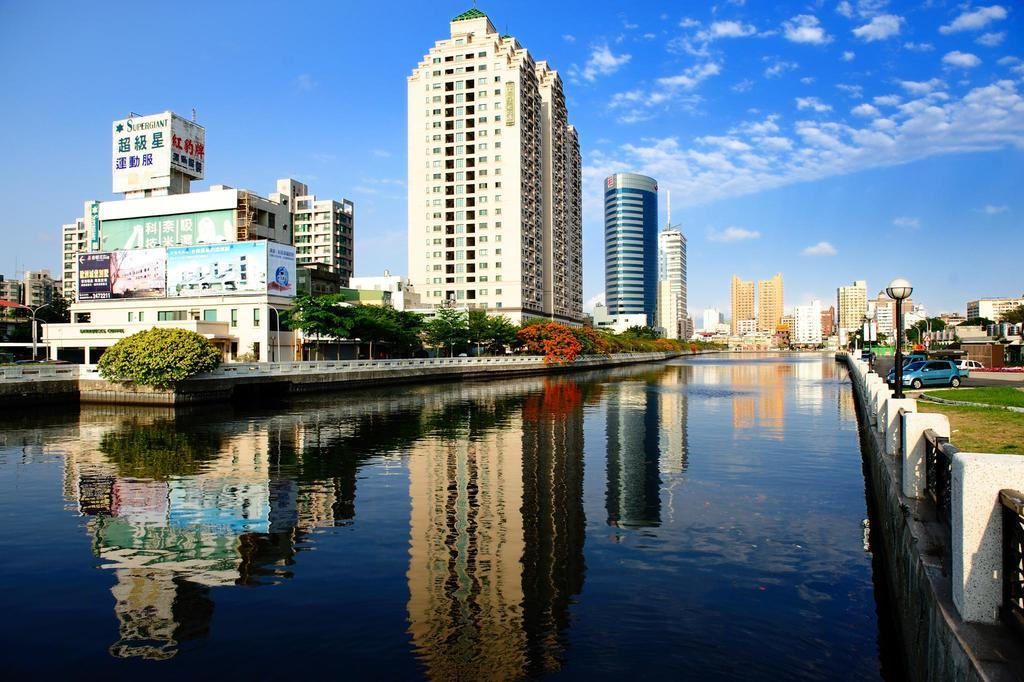What type of structures can be seen in the image? There are buildings in the image. What natural element is present in the image? There is a small water pond in the front side of the image. What vehicles are parked in the image? Cars are parked on the road side on the right side of the image. How many slaves are visible in the image? There are no slaves present in the image. What type of machine is being used to sleep in the image? There is no machine for sleeping in the image, and the concept of sleeping is not relevant to the image. 